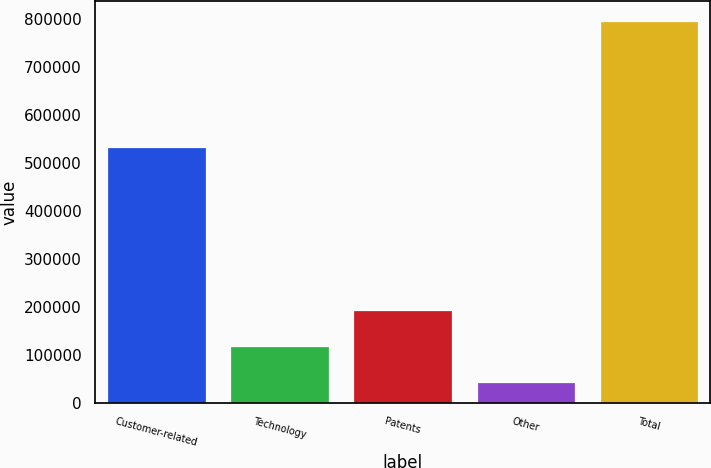Convert chart to OTSL. <chart><loc_0><loc_0><loc_500><loc_500><bar_chart><fcel>Customer-related<fcel>Technology<fcel>Patents<fcel>Other<fcel>Total<nl><fcel>532753<fcel>119006<fcel>194208<fcel>43804<fcel>795826<nl></chart> 